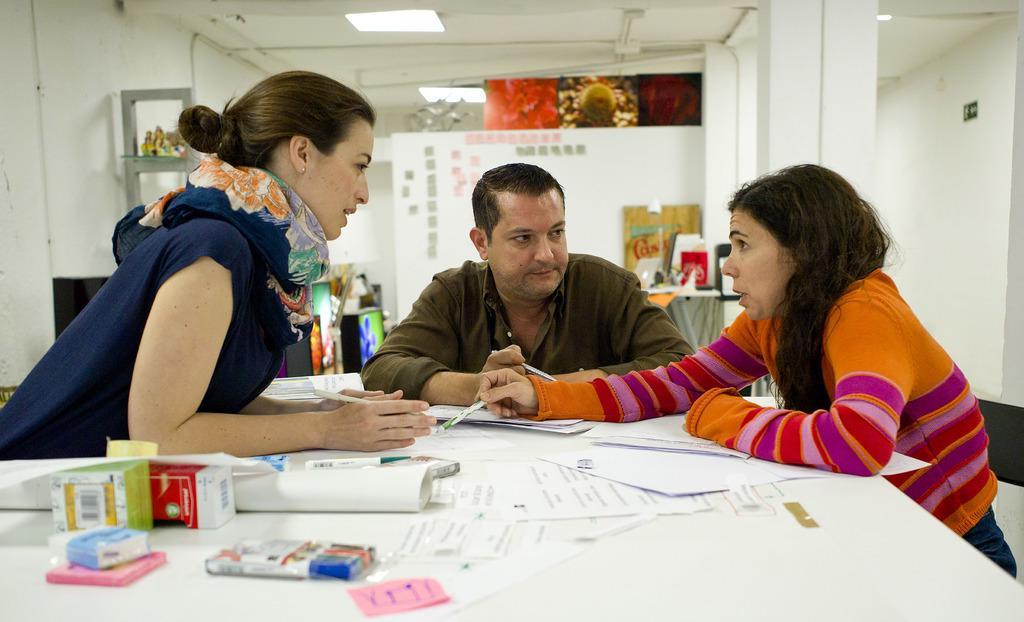Please provide a concise description of this image. In this image we can see person sitting on the chairs and a table is placed in front of them. On the table we can see papers, cardboard cartons, sticky notes, markers, earbuds and a thermometer. In the background there are walls, objects placed on the side table and an electric light. 